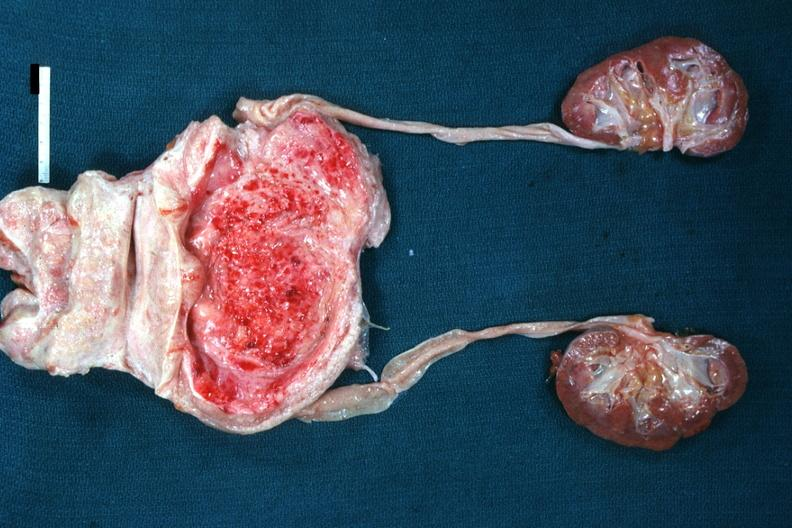does this image show enlarged nodular prostate with medial lobe enlargement bladder hypertrophy focal mucosal hemorrhages in bladder mild hydronephrosis very good example?
Answer the question using a single word or phrase. Yes 